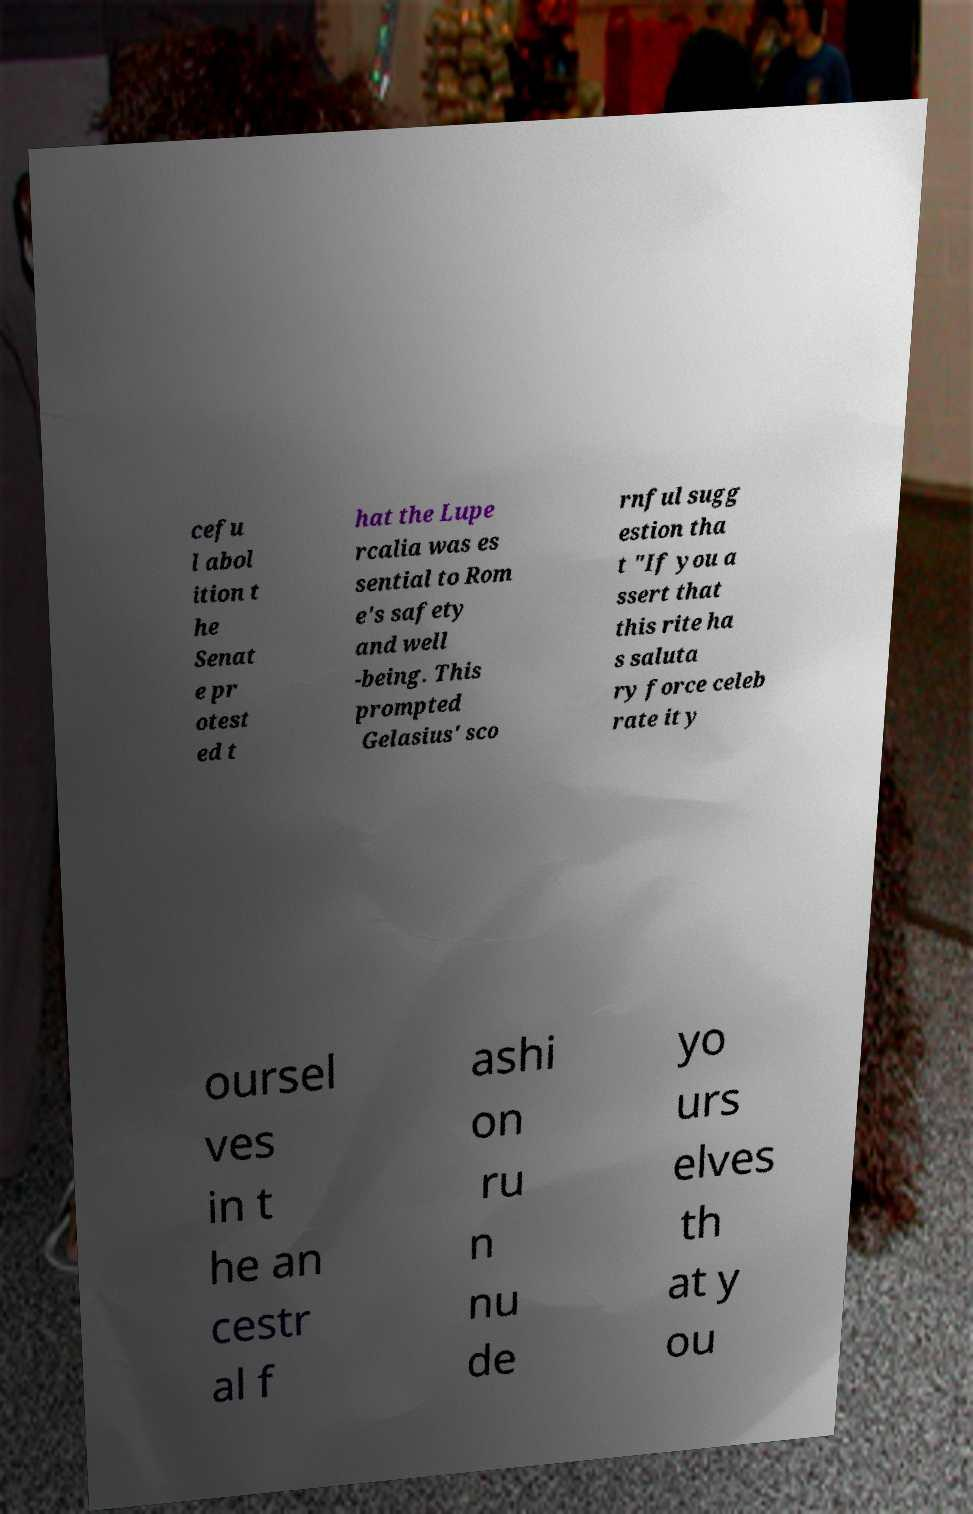For documentation purposes, I need the text within this image transcribed. Could you provide that? cefu l abol ition t he Senat e pr otest ed t hat the Lupe rcalia was es sential to Rom e's safety and well -being. This prompted Gelasius' sco rnful sugg estion tha t "If you a ssert that this rite ha s saluta ry force celeb rate it y oursel ves in t he an cestr al f ashi on ru n nu de yo urs elves th at y ou 